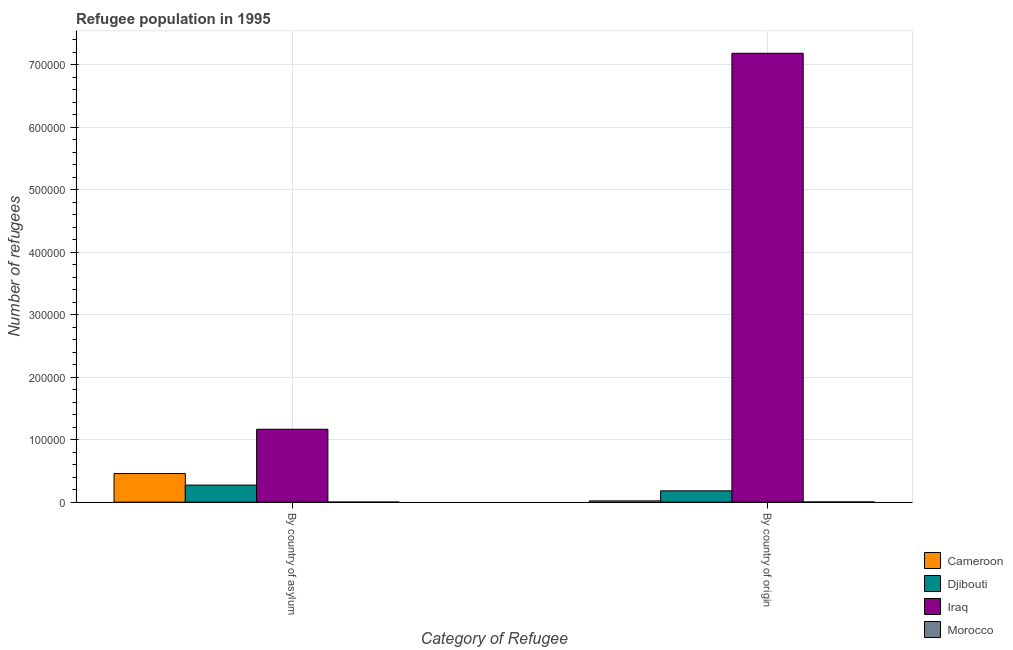How many different coloured bars are there?
Offer a terse response. 4. How many groups of bars are there?
Provide a succinct answer. 2. What is the label of the 2nd group of bars from the left?
Give a very brief answer. By country of origin. What is the number of refugees by country of origin in Djibouti?
Your answer should be very brief. 1.81e+04. Across all countries, what is the maximum number of refugees by country of origin?
Your response must be concise. 7.19e+05. Across all countries, what is the minimum number of refugees by country of asylum?
Ensure brevity in your answer.  55. In which country was the number of refugees by country of origin maximum?
Keep it short and to the point. Iraq. In which country was the number of refugees by country of origin minimum?
Your response must be concise. Morocco. What is the total number of refugees by country of origin in the graph?
Provide a short and direct response. 7.39e+05. What is the difference between the number of refugees by country of origin in Iraq and that in Djibouti?
Make the answer very short. 7.01e+05. What is the difference between the number of refugees by country of origin in Djibouti and the number of refugees by country of asylum in Iraq?
Ensure brevity in your answer.  -9.86e+04. What is the average number of refugees by country of asylum per country?
Provide a short and direct response. 4.75e+04. What is the difference between the number of refugees by country of origin and number of refugees by country of asylum in Djibouti?
Make the answer very short. -9215. In how many countries, is the number of refugees by country of origin greater than 60000 ?
Make the answer very short. 1. What is the ratio of the number of refugees by country of origin in Djibouti to that in Iraq?
Provide a short and direct response. 0.03. Is the number of refugees by country of origin in Iraq less than that in Morocco?
Ensure brevity in your answer.  No. What does the 3rd bar from the left in By country of origin represents?
Ensure brevity in your answer.  Iraq. What does the 1st bar from the right in By country of origin represents?
Provide a succinct answer. Morocco. Are all the bars in the graph horizontal?
Offer a terse response. No. How many countries are there in the graph?
Offer a terse response. 4. What is the difference between two consecutive major ticks on the Y-axis?
Ensure brevity in your answer.  1.00e+05. Are the values on the major ticks of Y-axis written in scientific E-notation?
Give a very brief answer. No. Does the graph contain any zero values?
Make the answer very short. No. Does the graph contain grids?
Give a very brief answer. Yes. What is the title of the graph?
Provide a short and direct response. Refugee population in 1995. What is the label or title of the X-axis?
Your answer should be compact. Category of Refugee. What is the label or title of the Y-axis?
Offer a very short reply. Number of refugees. What is the Number of refugees of Cameroon in By country of asylum?
Provide a short and direct response. 4.58e+04. What is the Number of refugees of Djibouti in By country of asylum?
Provide a short and direct response. 2.73e+04. What is the Number of refugees of Iraq in By country of asylum?
Make the answer very short. 1.17e+05. What is the Number of refugees of Morocco in By country of asylum?
Ensure brevity in your answer.  55. What is the Number of refugees of Cameroon in By country of origin?
Keep it short and to the point. 2017. What is the Number of refugees of Djibouti in By country of origin?
Offer a very short reply. 1.81e+04. What is the Number of refugees in Iraq in By country of origin?
Provide a short and direct response. 7.19e+05. What is the Number of refugees of Morocco in By country of origin?
Provide a succinct answer. 301. Across all Category of Refugee, what is the maximum Number of refugees of Cameroon?
Give a very brief answer. 4.58e+04. Across all Category of Refugee, what is the maximum Number of refugees of Djibouti?
Offer a terse response. 2.73e+04. Across all Category of Refugee, what is the maximum Number of refugees of Iraq?
Your answer should be compact. 7.19e+05. Across all Category of Refugee, what is the maximum Number of refugees of Morocco?
Your answer should be very brief. 301. Across all Category of Refugee, what is the minimum Number of refugees of Cameroon?
Give a very brief answer. 2017. Across all Category of Refugee, what is the minimum Number of refugees of Djibouti?
Ensure brevity in your answer.  1.81e+04. Across all Category of Refugee, what is the minimum Number of refugees in Iraq?
Provide a succinct answer. 1.17e+05. Across all Category of Refugee, what is the minimum Number of refugees of Morocco?
Provide a short and direct response. 55. What is the total Number of refugees in Cameroon in the graph?
Ensure brevity in your answer.  4.78e+04. What is the total Number of refugees of Djibouti in the graph?
Make the answer very short. 4.54e+04. What is the total Number of refugees in Iraq in the graph?
Make the answer very short. 8.35e+05. What is the total Number of refugees of Morocco in the graph?
Make the answer very short. 356. What is the difference between the Number of refugees of Cameroon in By country of asylum and that in By country of origin?
Your response must be concise. 4.38e+04. What is the difference between the Number of refugees in Djibouti in By country of asylum and that in By country of origin?
Your answer should be very brief. 9215. What is the difference between the Number of refugees of Iraq in By country of asylum and that in By country of origin?
Your response must be concise. -6.02e+05. What is the difference between the Number of refugees in Morocco in By country of asylum and that in By country of origin?
Keep it short and to the point. -246. What is the difference between the Number of refugees in Cameroon in By country of asylum and the Number of refugees in Djibouti in By country of origin?
Provide a succinct answer. 2.77e+04. What is the difference between the Number of refugees in Cameroon in By country of asylum and the Number of refugees in Iraq in By country of origin?
Offer a very short reply. -6.73e+05. What is the difference between the Number of refugees of Cameroon in By country of asylum and the Number of refugees of Morocco in By country of origin?
Ensure brevity in your answer.  4.55e+04. What is the difference between the Number of refugees in Djibouti in By country of asylum and the Number of refugees in Iraq in By country of origin?
Give a very brief answer. -6.91e+05. What is the difference between the Number of refugees in Djibouti in By country of asylum and the Number of refugees in Morocco in By country of origin?
Your answer should be very brief. 2.70e+04. What is the difference between the Number of refugees of Iraq in By country of asylum and the Number of refugees of Morocco in By country of origin?
Provide a succinct answer. 1.16e+05. What is the average Number of refugees in Cameroon per Category of Refugee?
Your answer should be very brief. 2.39e+04. What is the average Number of refugees of Djibouti per Category of Refugee?
Provide a succinct answer. 2.27e+04. What is the average Number of refugees in Iraq per Category of Refugee?
Give a very brief answer. 4.18e+05. What is the average Number of refugees of Morocco per Category of Refugee?
Make the answer very short. 178. What is the difference between the Number of refugees of Cameroon and Number of refugees of Djibouti in By country of asylum?
Provide a short and direct response. 1.85e+04. What is the difference between the Number of refugees in Cameroon and Number of refugees in Iraq in By country of asylum?
Give a very brief answer. -7.09e+04. What is the difference between the Number of refugees of Cameroon and Number of refugees of Morocco in By country of asylum?
Offer a terse response. 4.57e+04. What is the difference between the Number of refugees in Djibouti and Number of refugees in Iraq in By country of asylum?
Ensure brevity in your answer.  -8.94e+04. What is the difference between the Number of refugees of Djibouti and Number of refugees of Morocco in By country of asylum?
Offer a very short reply. 2.73e+04. What is the difference between the Number of refugees of Iraq and Number of refugees of Morocco in By country of asylum?
Provide a short and direct response. 1.17e+05. What is the difference between the Number of refugees in Cameroon and Number of refugees in Djibouti in By country of origin?
Your answer should be very brief. -1.61e+04. What is the difference between the Number of refugees of Cameroon and Number of refugees of Iraq in By country of origin?
Your answer should be compact. -7.17e+05. What is the difference between the Number of refugees of Cameroon and Number of refugees of Morocco in By country of origin?
Keep it short and to the point. 1716. What is the difference between the Number of refugees of Djibouti and Number of refugees of Iraq in By country of origin?
Provide a succinct answer. -7.01e+05. What is the difference between the Number of refugees in Djibouti and Number of refugees in Morocco in By country of origin?
Provide a succinct answer. 1.78e+04. What is the difference between the Number of refugees of Iraq and Number of refugees of Morocco in By country of origin?
Provide a short and direct response. 7.18e+05. What is the ratio of the Number of refugees in Cameroon in By country of asylum to that in By country of origin?
Offer a very short reply. 22.7. What is the ratio of the Number of refugees in Djibouti in By country of asylum to that in By country of origin?
Give a very brief answer. 1.51. What is the ratio of the Number of refugees in Iraq in By country of asylum to that in By country of origin?
Ensure brevity in your answer.  0.16. What is the ratio of the Number of refugees in Morocco in By country of asylum to that in By country of origin?
Ensure brevity in your answer.  0.18. What is the difference between the highest and the second highest Number of refugees in Cameroon?
Provide a succinct answer. 4.38e+04. What is the difference between the highest and the second highest Number of refugees in Djibouti?
Keep it short and to the point. 9215. What is the difference between the highest and the second highest Number of refugees of Iraq?
Your answer should be compact. 6.02e+05. What is the difference between the highest and the second highest Number of refugees of Morocco?
Your answer should be very brief. 246. What is the difference between the highest and the lowest Number of refugees in Cameroon?
Your response must be concise. 4.38e+04. What is the difference between the highest and the lowest Number of refugees of Djibouti?
Ensure brevity in your answer.  9215. What is the difference between the highest and the lowest Number of refugees of Iraq?
Your answer should be compact. 6.02e+05. What is the difference between the highest and the lowest Number of refugees of Morocco?
Provide a succinct answer. 246. 